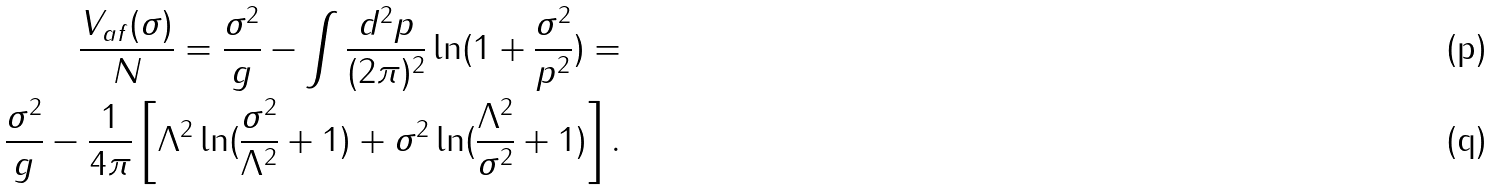<formula> <loc_0><loc_0><loc_500><loc_500>\frac { V _ { a f } ( \sigma ) } { N } = \frac { \sigma ^ { 2 } } { g } - \int \frac { d ^ { 2 } p } { ( 2 \pi ) ^ { 2 } } \ln ( 1 + \frac { \sigma ^ { 2 } } { p ^ { 2 } } ) = \\ \frac { \sigma ^ { 2 } } { g } - \frac { 1 } { 4 \pi } \left [ \Lambda ^ { 2 } \ln ( \frac { \sigma ^ { 2 } } { \Lambda ^ { 2 } } + 1 ) + \sigma ^ { 2 } \ln ( \frac { \Lambda ^ { 2 } } { \sigma ^ { 2 } } + 1 ) \right ] .</formula> 